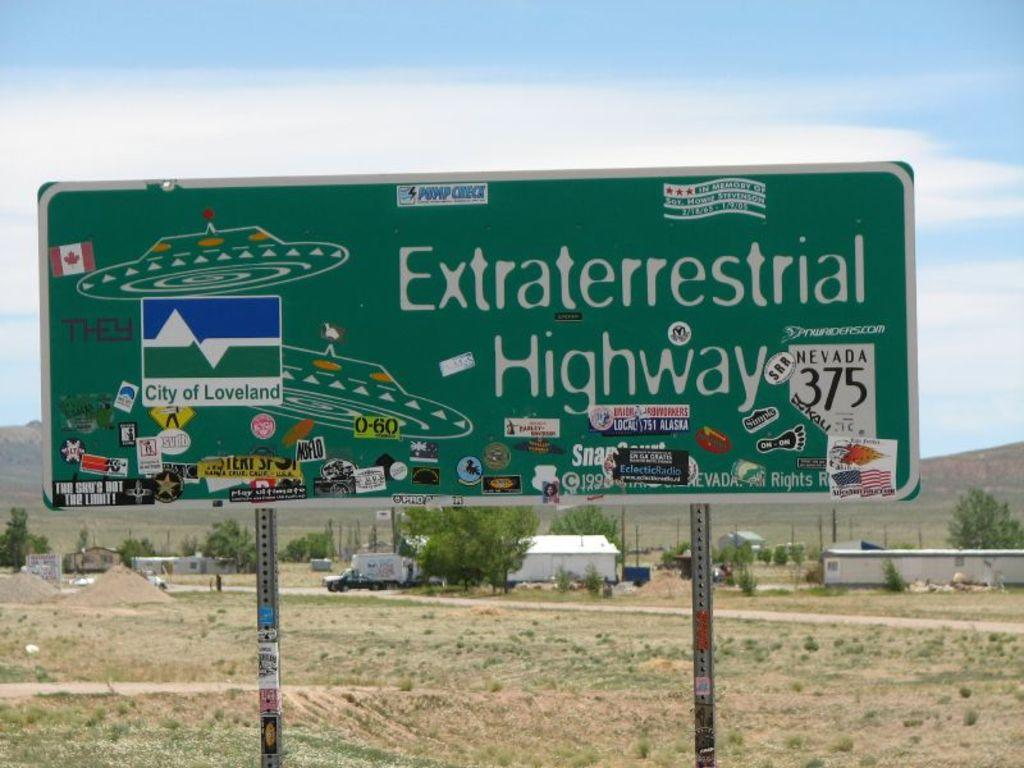<image>
Present a compact description of the photo's key features. A sign that reads "Extraterrestrial Highway" with flying saucers on it. 